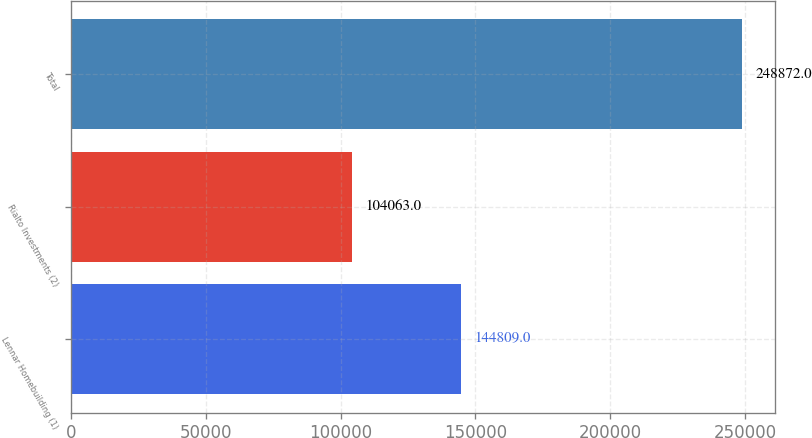Convert chart. <chart><loc_0><loc_0><loc_500><loc_500><bar_chart><fcel>Lennar Homebuilding (1)<fcel>Rialto Investments (2)<fcel>Total<nl><fcel>144809<fcel>104063<fcel>248872<nl></chart> 